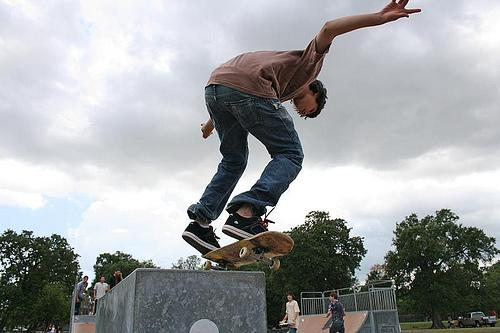What is the best material for a skateboard?

Choices:
A) maple
B) pine
C) palm
D) coconut maple 